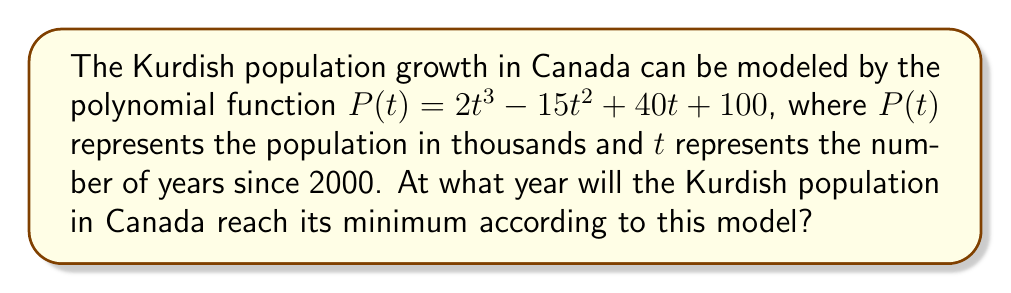Could you help me with this problem? To find the year when the Kurdish population reaches its minimum, we need to follow these steps:

1) The minimum point of a polynomial function occurs at a local minimum, which can be found by determining where the derivative of the function equals zero.

2) First, let's find the derivative of $P(t)$:
   $P'(t) = 6t^2 - 30t + 40$

3) Set the derivative equal to zero and solve for $t$:
   $6t^2 - 30t + 40 = 0$

4) This is a quadratic equation. We can solve it using the quadratic formula:
   $t = \frac{-b \pm \sqrt{b^2 - 4ac}}{2a}$

   Where $a = 6$, $b = -30$, and $c = 40$

5) Plugging in these values:
   $t = \frac{30 \pm \sqrt{(-30)^2 - 4(6)(40)}}{2(6)}$
   $= \frac{30 \pm \sqrt{900 - 960}}{12}$
   $= \frac{30 \pm \sqrt{-60}}{12}$

6) Since we can't have a negative value under the square root in real numbers, there's only one solution:
   $t = \frac{30}{12} = 2.5$

7) This means the population reaches its minimum 2.5 years after 2000, which is mid-2002.
Answer: 2002 